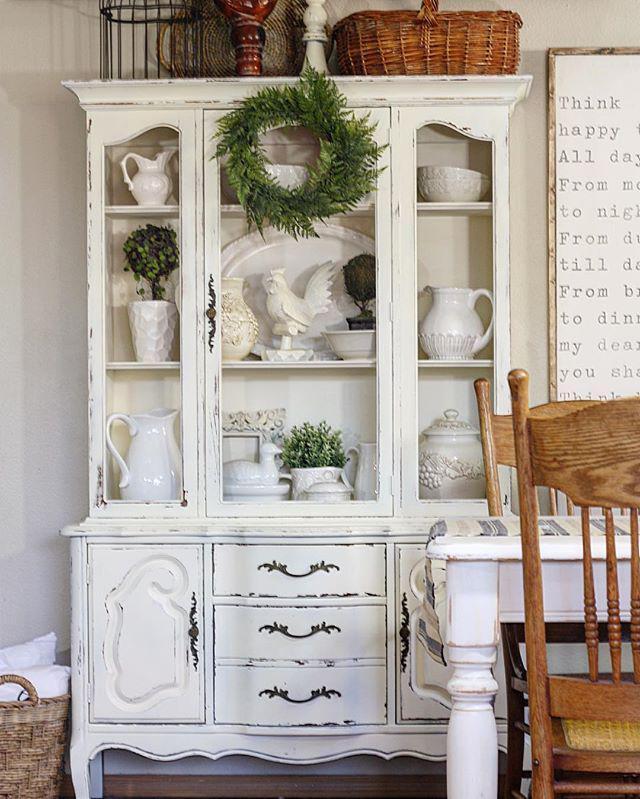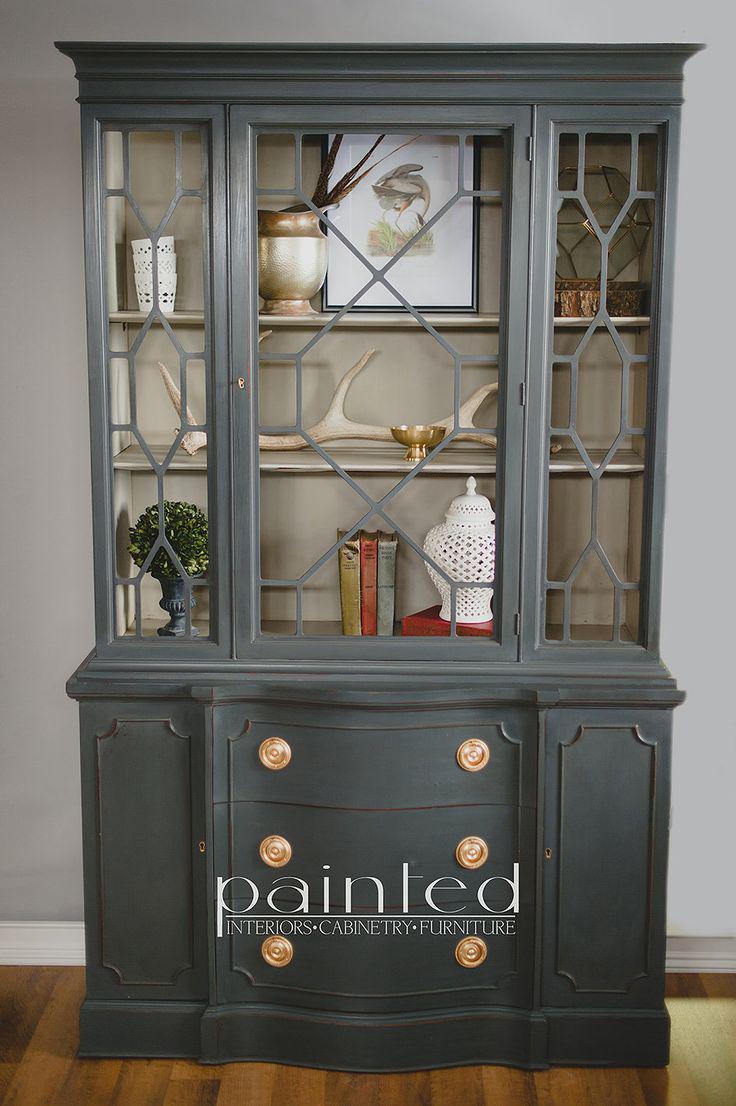The first image is the image on the left, the second image is the image on the right. Assess this claim about the two images: "The cabinet in the image on the right is charcoal grey, while the one on the left is white.". Correct or not? Answer yes or no. Yes. The first image is the image on the left, the second image is the image on the right. For the images displayed, is the sentence "One white hutch has a straight top and three shelves in the upper section, and a gray hutch has an upper center glass door that is wider than the two side glass sections." factually correct? Answer yes or no. Yes. 